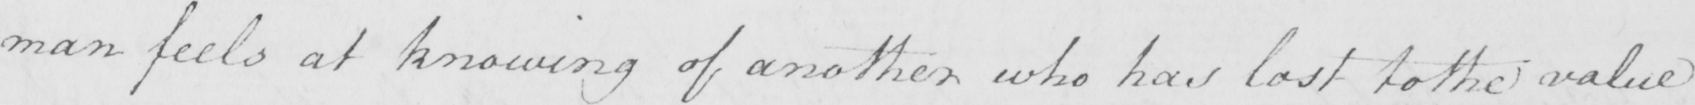Transcribe the text shown in this historical manuscript line. man feels at knowing of another who has lost to the value 